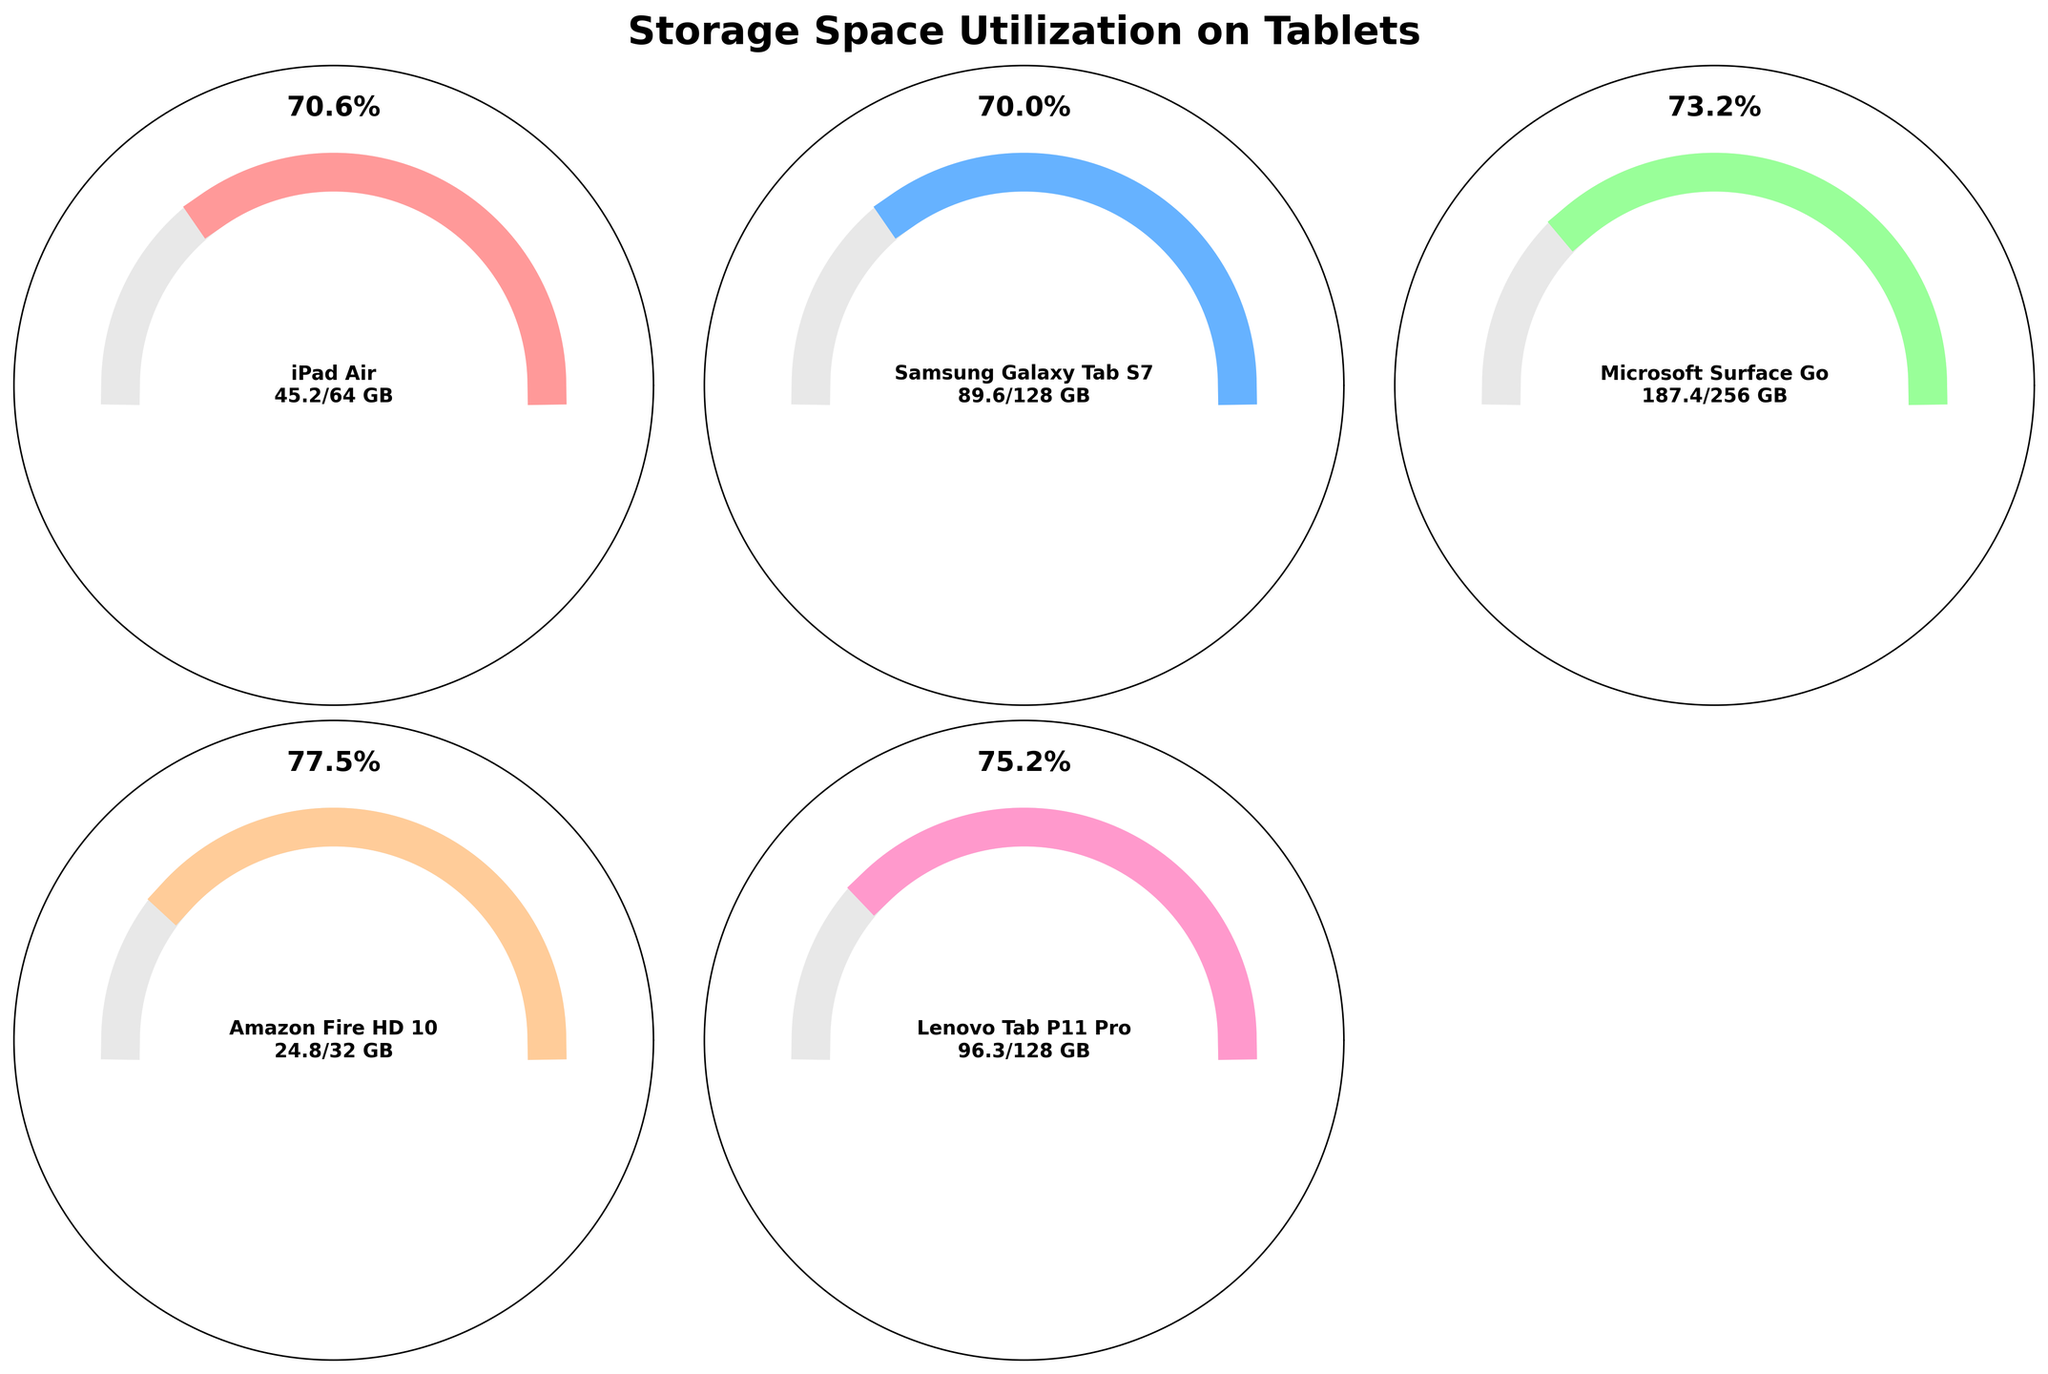What is the title of the figure? The title is usually located at the top of the figure, and it summarizes the main topic or subject of the visualization. The title in this case is "Storage Space Utilization on Tablets".
Answer: Storage Space Utilization on Tablets How many tablets are represented in the figure? Each gauge chart represents one tablet. By counting the individual charts, we can determine the number of tablets shown in the figure.
Answer: 5 Which tablet has the highest used space in GB? By examining each gauge chart, we can look for the one with the largest used space value shown. In this case, the Microsoft Surface Go has the highest used space of 187.4 GB.
Answer: Microsoft Surface Go What percentage of space is used on the Samsung Galaxy Tab S7? The percentage for used space is indicated on the gauge chart and can be read directly. For Samsung Galaxy Tab S7, it is 70%.
Answer: 70% Which tablet has the lowest available space in GB? The gauge charts also display the available space. By identifying the lowest value among them, we find that the Amazon Fire HD 10 has the lowest available space of 7.2 GB.
Answer: Amazon Fire HD 10 What is the total number of GB used across all tablets combined? Sum up the used space for all tablets: 45.2 (iPad Air) + 89.6 (Samsung Galaxy Tab S7) + 187.4 (Microsoft Surface Go) + 24.8 (Amazon Fire HD 10) + 96.3 (Lenovo Tab P11 Pro). The total used space is 443.3 GB.
Answer: 443.3 GB Which tablet has the highest percentage of its storage space available? By looking at the gauge charts, we can compare the available space percentages. Microsoft Surface Go has 68.6 GB available out of 256 GB, or approximately 27%, which is the highest percentage.
Answer: Microsoft Surface Go What is the difference in used space between the iPad Air and the Lenovo Tab P11 Pro? The used space for iPad Air is 45.2 GB and for Lenovo Tab P11 Pro is 96.3 GB. The difference is 96.3 - 45.2 = 51.1 GB.
Answer: 51.1 GB 